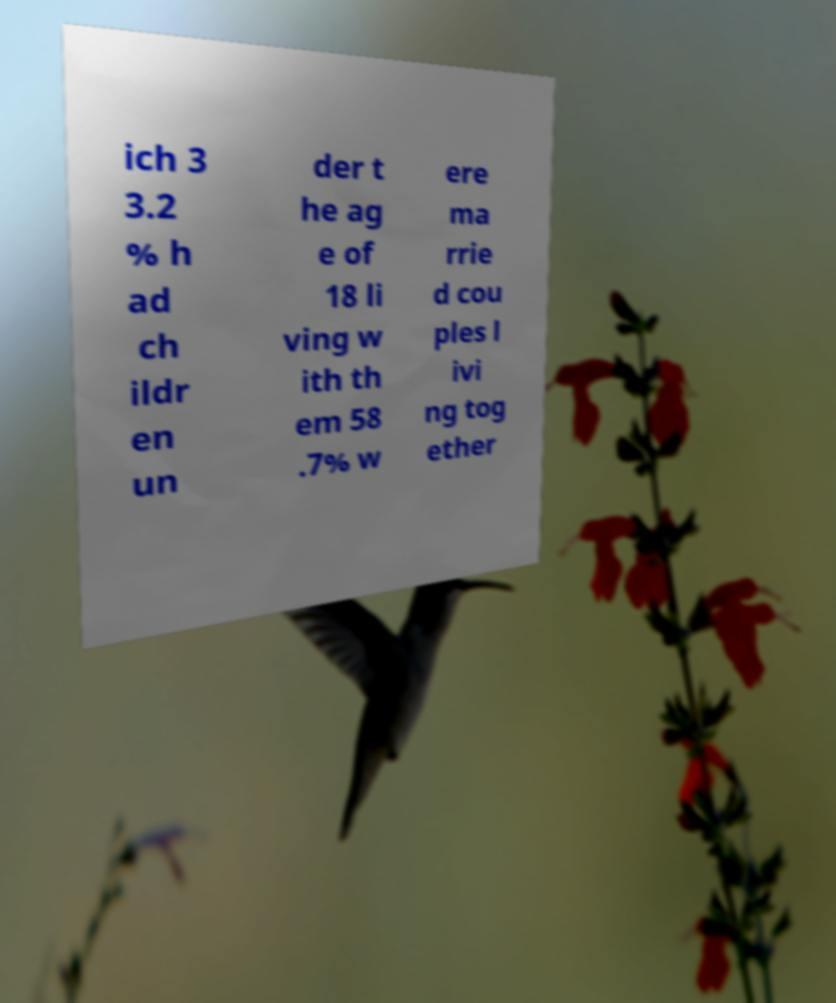I need the written content from this picture converted into text. Can you do that? ich 3 3.2 % h ad ch ildr en un der t he ag e of 18 li ving w ith th em 58 .7% w ere ma rrie d cou ples l ivi ng tog ether 